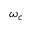<formula> <loc_0><loc_0><loc_500><loc_500>\omega _ { c }</formula> 